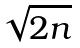<formula> <loc_0><loc_0><loc_500><loc_500>\sqrt { 2 n }</formula> 